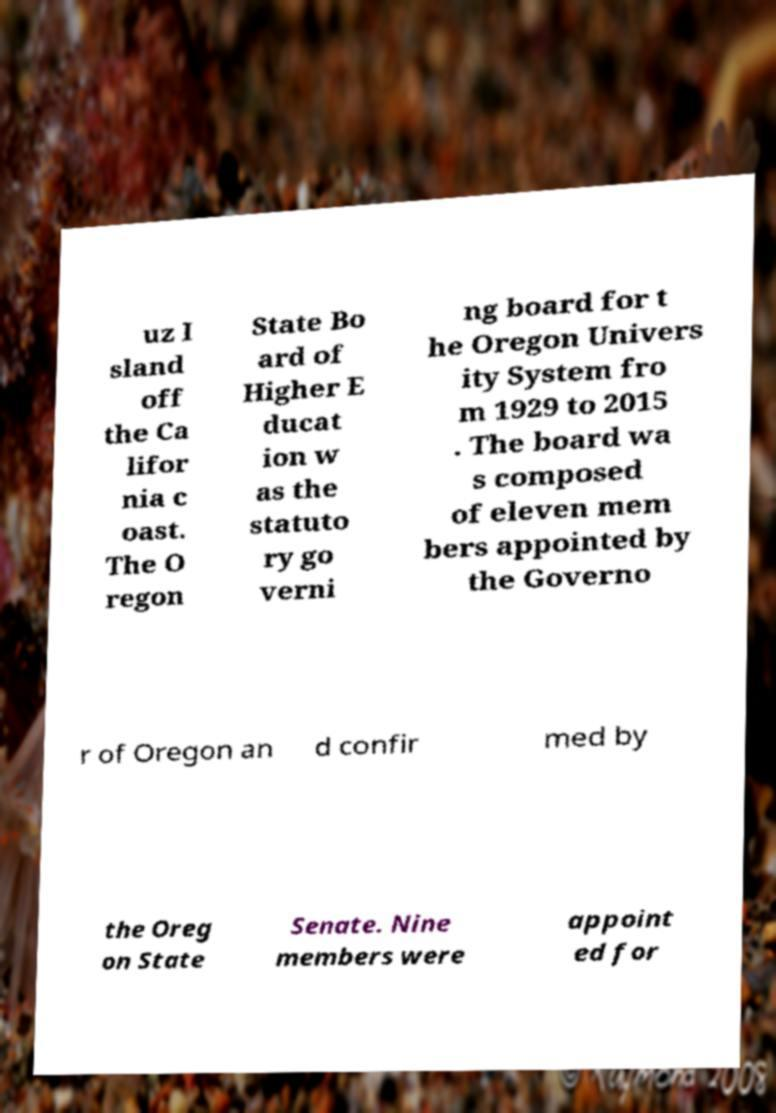There's text embedded in this image that I need extracted. Can you transcribe it verbatim? uz I sland off the Ca lifor nia c oast. The O regon State Bo ard of Higher E ducat ion w as the statuto ry go verni ng board for t he Oregon Univers ity System fro m 1929 to 2015 . The board wa s composed of eleven mem bers appointed by the Governo r of Oregon an d confir med by the Oreg on State Senate. Nine members were appoint ed for 